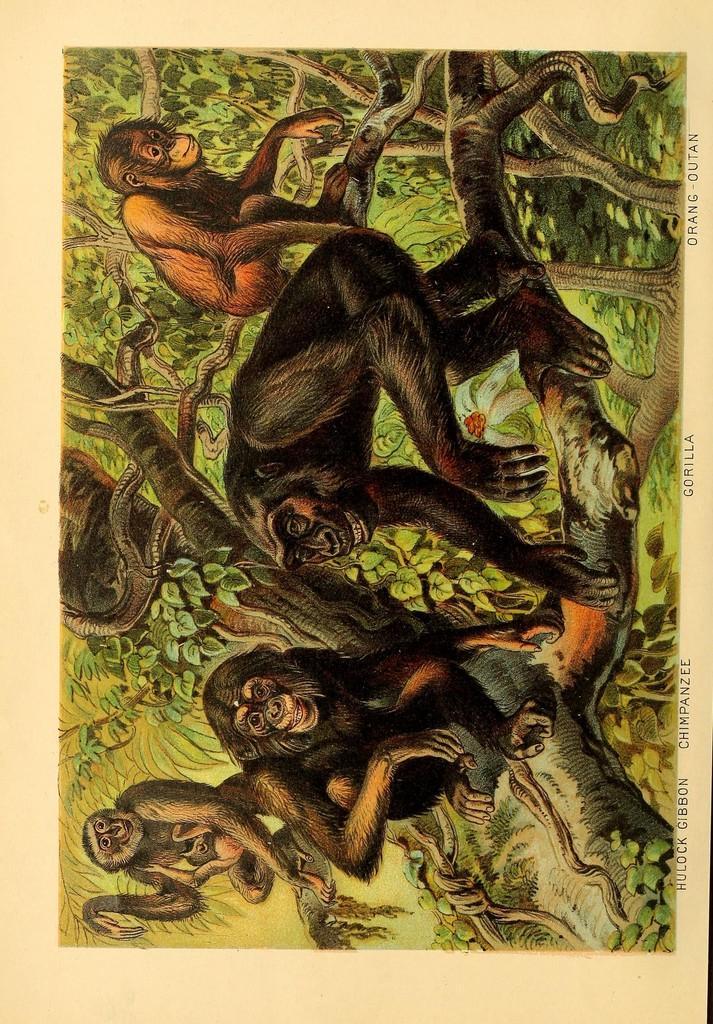Could you give a brief overview of what you see in this image? In this picture there are few monkeys which are in black color are sitting on the branches of trees. 